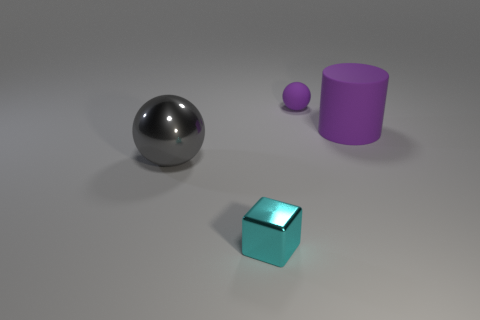What materials do the objects look like they are made from? The large ball has a shiny, reflective surface, which suggests it is made of metal. The small sphere has a matte finish, which could indicate that it is made of plastic or rubber. The cube has a slightly glossy appearance, hinting at a possibly plastic or painted wooden material, while the cylinder has a matte surface similar to the small sphere, suggesting it might also be composed of rubber or plastic. 